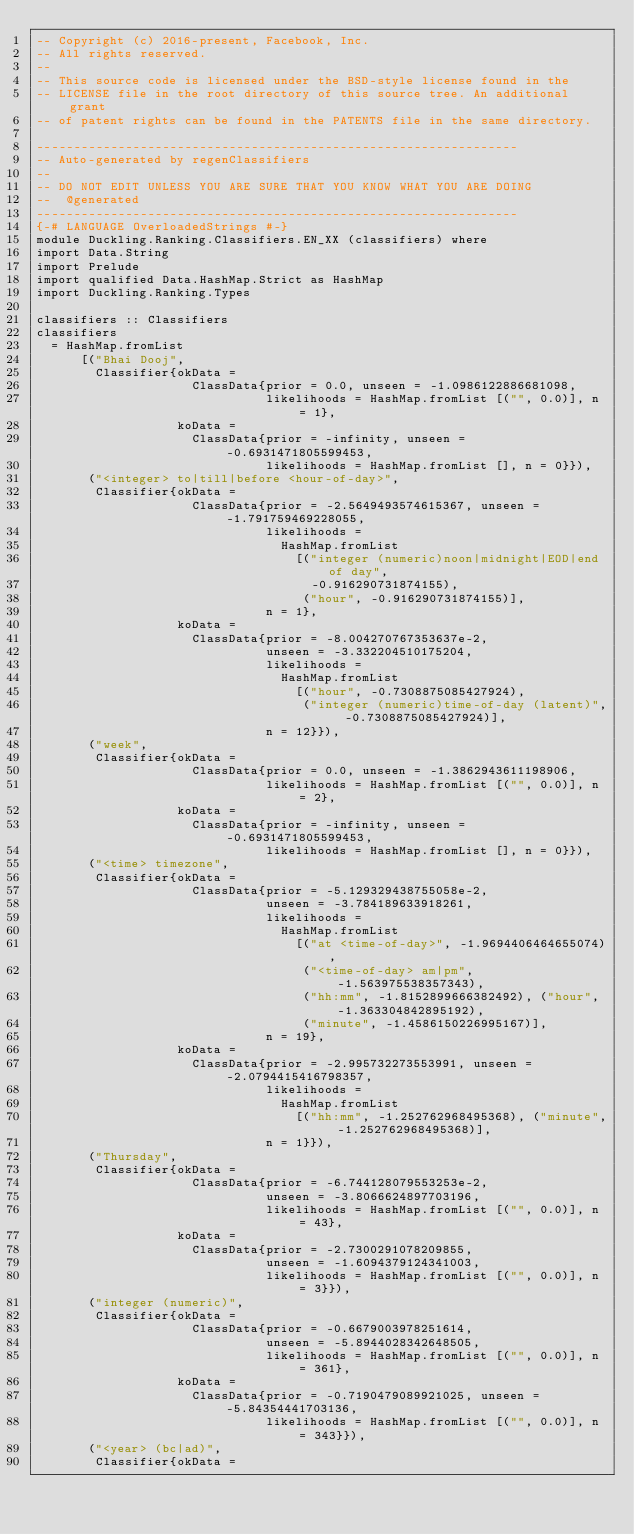<code> <loc_0><loc_0><loc_500><loc_500><_Haskell_>-- Copyright (c) 2016-present, Facebook, Inc.
-- All rights reserved.
--
-- This source code is licensed under the BSD-style license found in the
-- LICENSE file in the root directory of this source tree. An additional grant
-- of patent rights can be found in the PATENTS file in the same directory.

-----------------------------------------------------------------
-- Auto-generated by regenClassifiers
--
-- DO NOT EDIT UNLESS YOU ARE SURE THAT YOU KNOW WHAT YOU ARE DOING
--  @generated
-----------------------------------------------------------------
{-# LANGUAGE OverloadedStrings #-}
module Duckling.Ranking.Classifiers.EN_XX (classifiers) where
import Data.String
import Prelude
import qualified Data.HashMap.Strict as HashMap
import Duckling.Ranking.Types

classifiers :: Classifiers
classifiers
  = HashMap.fromList
      [("Bhai Dooj",
        Classifier{okData =
                     ClassData{prior = 0.0, unseen = -1.0986122886681098,
                               likelihoods = HashMap.fromList [("", 0.0)], n = 1},
                   koData =
                     ClassData{prior = -infinity, unseen = -0.6931471805599453,
                               likelihoods = HashMap.fromList [], n = 0}}),
       ("<integer> to|till|before <hour-of-day>",
        Classifier{okData =
                     ClassData{prior = -2.5649493574615367, unseen = -1.791759469228055,
                               likelihoods =
                                 HashMap.fromList
                                   [("integer (numeric)noon|midnight|EOD|end of day",
                                     -0.916290731874155),
                                    ("hour", -0.916290731874155)],
                               n = 1},
                   koData =
                     ClassData{prior = -8.004270767353637e-2,
                               unseen = -3.332204510175204,
                               likelihoods =
                                 HashMap.fromList
                                   [("hour", -0.7308875085427924),
                                    ("integer (numeric)time-of-day (latent)", -0.7308875085427924)],
                               n = 12}}),
       ("week",
        Classifier{okData =
                     ClassData{prior = 0.0, unseen = -1.3862943611198906,
                               likelihoods = HashMap.fromList [("", 0.0)], n = 2},
                   koData =
                     ClassData{prior = -infinity, unseen = -0.6931471805599453,
                               likelihoods = HashMap.fromList [], n = 0}}),
       ("<time> timezone",
        Classifier{okData =
                     ClassData{prior = -5.129329438755058e-2,
                               unseen = -3.784189633918261,
                               likelihoods =
                                 HashMap.fromList
                                   [("at <time-of-day>", -1.9694406464655074),
                                    ("<time-of-day> am|pm", -1.563975538357343),
                                    ("hh:mm", -1.8152899666382492), ("hour", -1.363304842895192),
                                    ("minute", -1.4586150226995167)],
                               n = 19},
                   koData =
                     ClassData{prior = -2.995732273553991, unseen = -2.0794415416798357,
                               likelihoods =
                                 HashMap.fromList
                                   [("hh:mm", -1.252762968495368), ("minute", -1.252762968495368)],
                               n = 1}}),
       ("Thursday",
        Classifier{okData =
                     ClassData{prior = -6.744128079553253e-2,
                               unseen = -3.8066624897703196,
                               likelihoods = HashMap.fromList [("", 0.0)], n = 43},
                   koData =
                     ClassData{prior = -2.7300291078209855,
                               unseen = -1.6094379124341003,
                               likelihoods = HashMap.fromList [("", 0.0)], n = 3}}),
       ("integer (numeric)",
        Classifier{okData =
                     ClassData{prior = -0.6679003978251614,
                               unseen = -5.8944028342648505,
                               likelihoods = HashMap.fromList [("", 0.0)], n = 361},
                   koData =
                     ClassData{prior = -0.7190479089921025, unseen = -5.84354441703136,
                               likelihoods = HashMap.fromList [("", 0.0)], n = 343}}),
       ("<year> (bc|ad)",
        Classifier{okData =</code> 